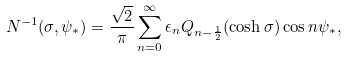<formula> <loc_0><loc_0><loc_500><loc_500>N ^ { - 1 } ( \sigma , \psi _ { * } ) = \frac { \sqrt { 2 } } { \pi } \sum ^ { \infty } _ { n = 0 } \epsilon _ { n } Q _ { n - \frac { 1 } { 2 } } ( \cosh \sigma ) \cos n \psi _ { * } ,</formula> 